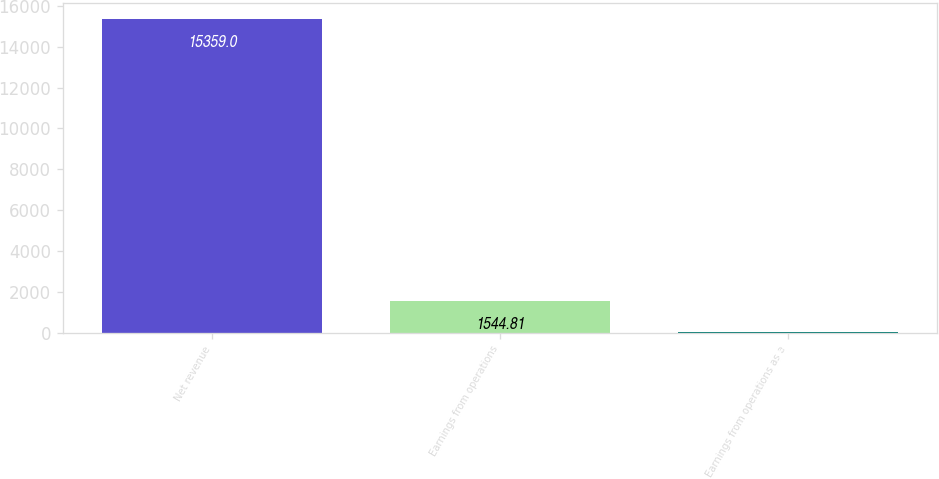Convert chart to OTSL. <chart><loc_0><loc_0><loc_500><loc_500><bar_chart><fcel>Net revenue<fcel>Earnings from operations<fcel>Earnings from operations as a<nl><fcel>15359<fcel>1544.81<fcel>9.9<nl></chart> 